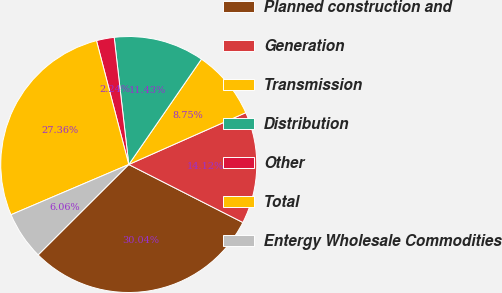Convert chart to OTSL. <chart><loc_0><loc_0><loc_500><loc_500><pie_chart><fcel>Planned construction and<fcel>Generation<fcel>Transmission<fcel>Distribution<fcel>Other<fcel>Total<fcel>Entergy Wholesale Commodities<nl><fcel>30.04%<fcel>14.12%<fcel>8.75%<fcel>11.43%<fcel>2.24%<fcel>27.36%<fcel>6.06%<nl></chart> 